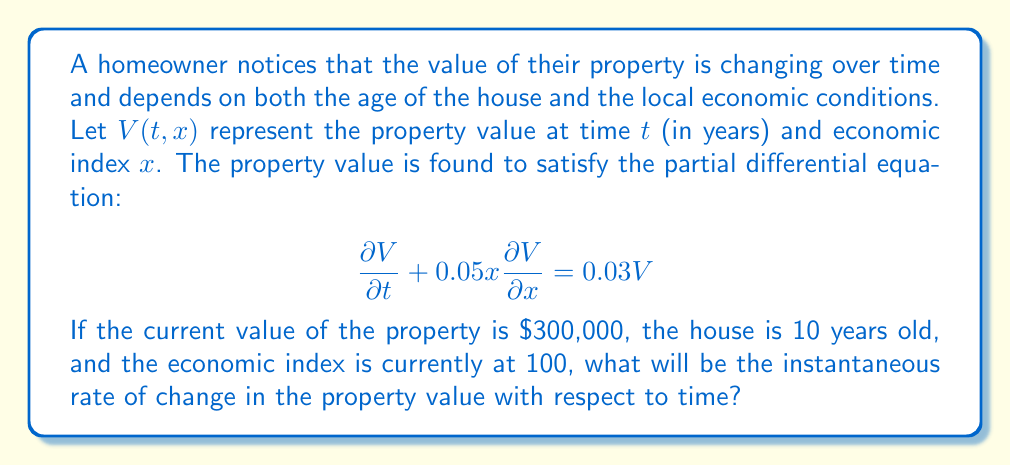Solve this math problem. To solve this problem, we need to use the given partial differential equation and the provided information. Let's break it down step-by-step:

1) The given PDE is:

   $$\frac{\partial V}{\partial t} + 0.05x\frac{\partial V}{\partial x} = 0.03V$$

2) We're asked to find $\frac{\partial V}{\partial t}$ at the current time. We can rearrange the equation to isolate this term:

   $$\frac{\partial V}{\partial t} = 0.03V - 0.05x\frac{\partial V}{\partial x}$$

3) We're given that:
   - $V = 300,000$ (current value)
   - $x = 100$ (current economic index)

4) We still need to find $\frac{\partial V}{\partial x}$. We can use the method of characteristics to determine that the general solution to this PDE is of the form:

   $$V(t,x) = Cx^{0.6}e^{0.03t}$$

   where $C$ is a constant.

5) Differentiating this with respect to $x$:

   $$\frac{\partial V}{\partial x} = 0.6Cx^{-0.4}e^{0.03t} = 0.6\frac{V}{x}$$

6) Substituting the known values into this equation:

   $$\frac{\partial V}{\partial x} = 0.6 \cdot \frac{300,000}{100} = 1,800$$

7) Now we can substitute all known values into the equation from step 2:

   $$\frac{\partial V}{\partial t} = 0.03 \cdot 300,000 - 0.05 \cdot 100 \cdot 1,800$$

8) Calculating:

   $$\frac{\partial V}{\partial t} = 9,000 - 9,000 = 0$$

Therefore, the instantaneous rate of change in the property value with respect to time is $0.
Answer: $\frac{\partial V}{\partial t} = 0$ 